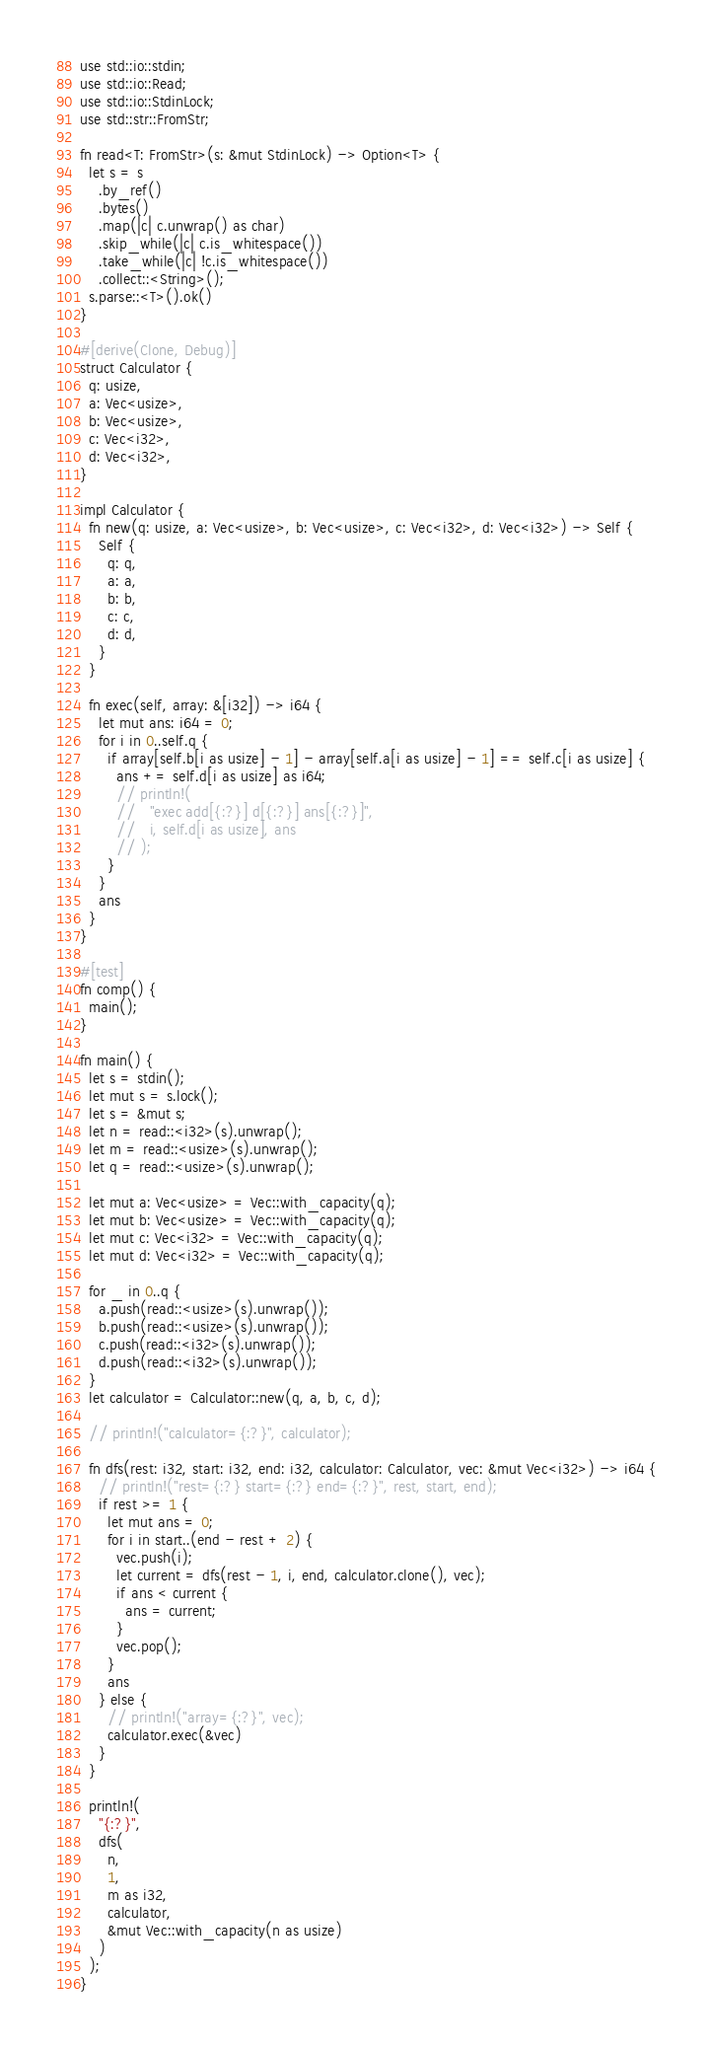<code> <loc_0><loc_0><loc_500><loc_500><_Rust_>use std::io::stdin;
use std::io::Read;
use std::io::StdinLock;
use std::str::FromStr;

fn read<T: FromStr>(s: &mut StdinLock) -> Option<T> {
  let s = s
    .by_ref()
    .bytes()
    .map(|c| c.unwrap() as char)
    .skip_while(|c| c.is_whitespace())
    .take_while(|c| !c.is_whitespace())
    .collect::<String>();
  s.parse::<T>().ok()
}

#[derive(Clone, Debug)]
struct Calculator {
  q: usize,
  a: Vec<usize>,
  b: Vec<usize>,
  c: Vec<i32>,
  d: Vec<i32>,
}

impl Calculator {
  fn new(q: usize, a: Vec<usize>, b: Vec<usize>, c: Vec<i32>, d: Vec<i32>) -> Self {
    Self {
      q: q,
      a: a,
      b: b,
      c: c,
      d: d,
    }
  }

  fn exec(self, array: &[i32]) -> i64 {
    let mut ans: i64 = 0;
    for i in 0..self.q {
      if array[self.b[i as usize] - 1] - array[self.a[i as usize] - 1] == self.c[i as usize] {
        ans += self.d[i as usize] as i64;
        // println!(
        //   "exec add[{:?}] d[{:?}] ans[{:?}]",
        //   i, self.d[i as usize], ans
        // );
      }
    }
    ans
  }
}

#[test]
fn comp() {
  main();
}

fn main() {
  let s = stdin();
  let mut s = s.lock();
  let s = &mut s;
  let n = read::<i32>(s).unwrap();
  let m = read::<usize>(s).unwrap();
  let q = read::<usize>(s).unwrap();

  let mut a: Vec<usize> = Vec::with_capacity(q);
  let mut b: Vec<usize> = Vec::with_capacity(q);
  let mut c: Vec<i32> = Vec::with_capacity(q);
  let mut d: Vec<i32> = Vec::with_capacity(q);

  for _ in 0..q {
    a.push(read::<usize>(s).unwrap());
    b.push(read::<usize>(s).unwrap());
    c.push(read::<i32>(s).unwrap());
    d.push(read::<i32>(s).unwrap());
  }
  let calculator = Calculator::new(q, a, b, c, d);

  // println!("calculator={:?}", calculator);

  fn dfs(rest: i32, start: i32, end: i32, calculator: Calculator, vec: &mut Vec<i32>) -> i64 {
    // println!("rest={:?} start={:?} end={:?}", rest, start, end);
    if rest >= 1 {
      let mut ans = 0;
      for i in start..(end - rest + 2) {
        vec.push(i);
        let current = dfs(rest - 1, i, end, calculator.clone(), vec);
        if ans < current {
          ans = current;
        }
        vec.pop();
      }
      ans
    } else {
      // println!("array={:?}", vec);
      calculator.exec(&vec)
    }
  }

  println!(
    "{:?}",
    dfs(
      n,
      1,
      m as i32,
      calculator,
      &mut Vec::with_capacity(n as usize)
    )
  );
}</code> 